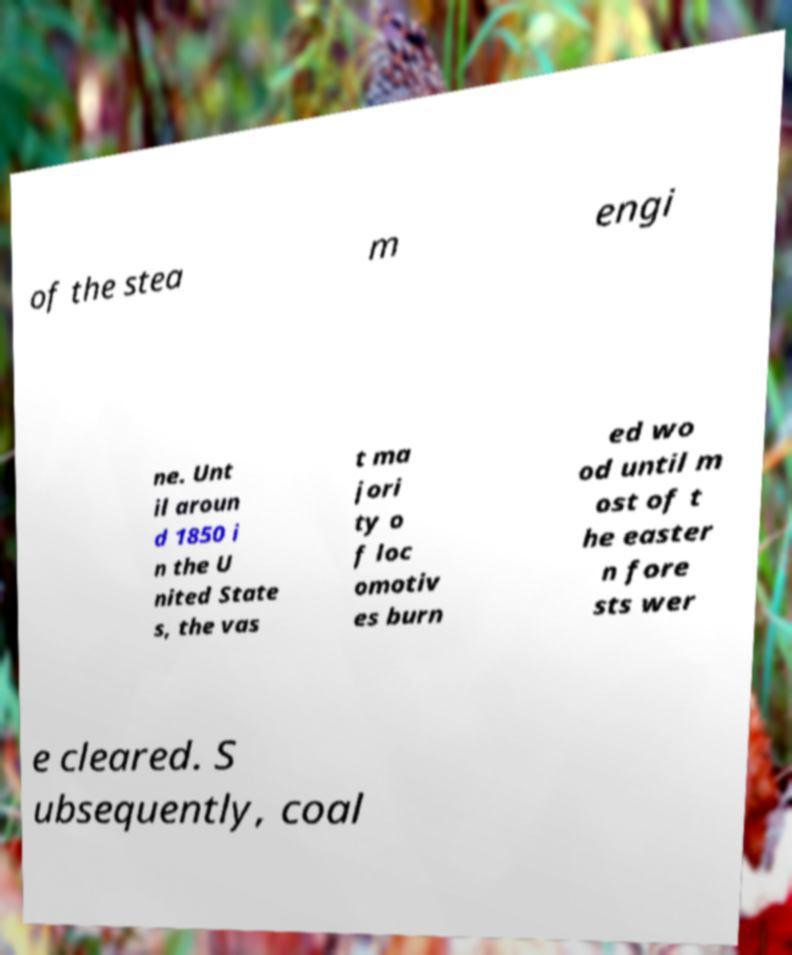There's text embedded in this image that I need extracted. Can you transcribe it verbatim? of the stea m engi ne. Unt il aroun d 1850 i n the U nited State s, the vas t ma jori ty o f loc omotiv es burn ed wo od until m ost of t he easter n fore sts wer e cleared. S ubsequently, coal 